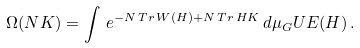Convert formula to latex. <formula><loc_0><loc_0><loc_500><loc_500>\Omega ( N K ) = \int \, e ^ { - N \, T r \, W ( H ) + N \, T r \, H K } \, d \mu _ { G } U E ( H ) \, .</formula> 